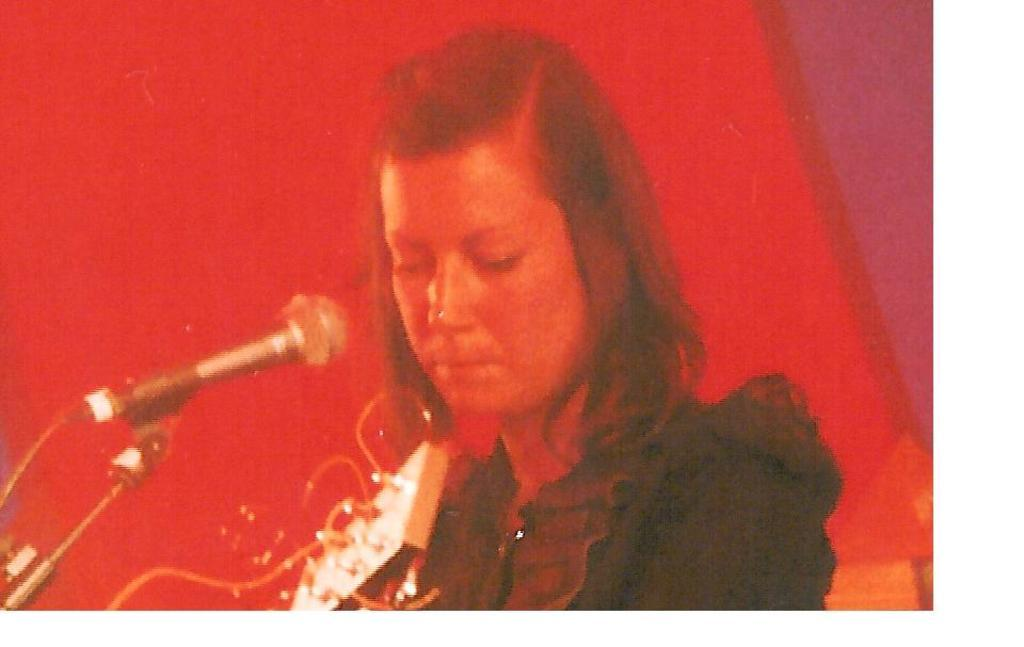What is the main subject of the image? There is a person in the image. What is the person holding in the image? The person is holding a musical instrument. What is in front of the person that might be used for amplifying sound? There is a microphone with a stand in front of the person. What color is the background of the image? The background of the image is red. What type of agreement is being discussed between the person and their uncle in the image? There is no mention of an uncle or any agreement in the image; it only features a person holding a musical instrument and a microphone with a stand. 